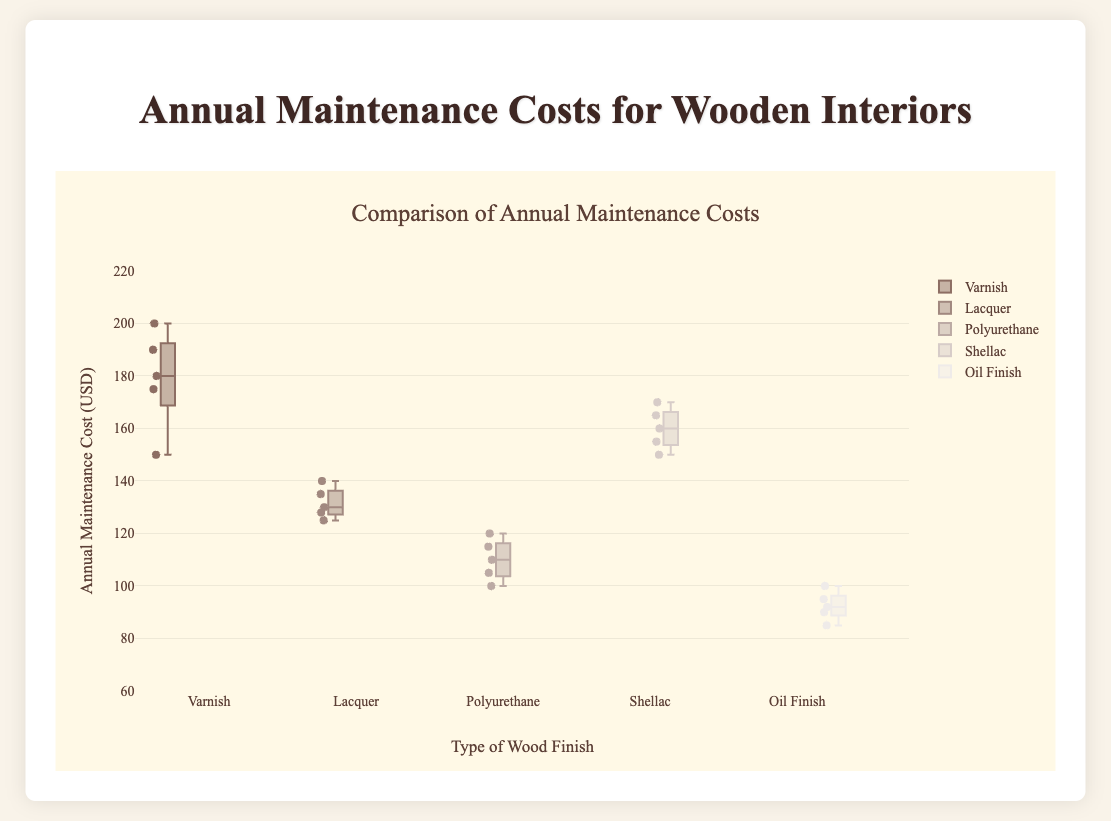What is the title of the figure? The title of the figure is located at the top and summarizes the content of the plot. If you look there, you can see it.
Answer: Annual Maintenance Costs for Wooden Interiors What is the range of the y-axis? The y-axis range is provided on the plot, showing the minimum and maximum values it can represent. The plot shows the y-axis range from 60 to 220.
Answer: 60 to 220 Which type of wood finish has the lowest median annual maintenance cost? The median for each wood finish can be found by looking at the central line inside the box of each box plot. The box plot for Oil Finish has the lowest central line compared to other finishes.
Answer: Oil Finish What is the median annual maintenance cost for shellac finish? To find the median value, look at the central line inside the box for the Shellac finish. In the plot, this line is at 160 USD.
Answer: 160 USD How many types of wood finishes are compared in this figure? Each box plot represents a different wood finish. Counting the names on the x-axis indicates there are 5 types of wood finishes.
Answer: 5 Which type of wood finish has the highest variability in annual maintenance costs? Variability in a box plot is shown by the length of the box and the whiskers. By comparing the lengths, Varnish has the highest spread of values from its minimum to maximum values.
Answer: Varnish What is the interquartile range (IQR) for the polyurethane finish? The IQR is the difference between the upper quartile (Q3) and the lower quartile (Q1) of the box plot. For Polyurethane, Q3 is 115 and Q1 is 105. Therefore, the IQR is 115 - 105 = 10.
Answer: 10 Which wood finish has at least one maintenance cost data point above 200 USD? Points that are plotted beyond the whiskers represent outliers. By inspecting the plot, Varnish has a point above 200 USD.
Answer: Varnish Between Lacquer and Polyurethane, which has the higher median annual maintenance cost? Look at the central lines inside the boxes for Lacquer and Polyurethane. The central line (median) for Lacquer is higher than that for Polyurethane.
Answer: Lacquer What type of wood finish has the lowest minimum annual maintenance cost? The minimum cost is the lowest point of the lower whisker in the box plot. Comparing the whiskers, Oil Finish has the lowest minimum cost.
Answer: Oil Finish 